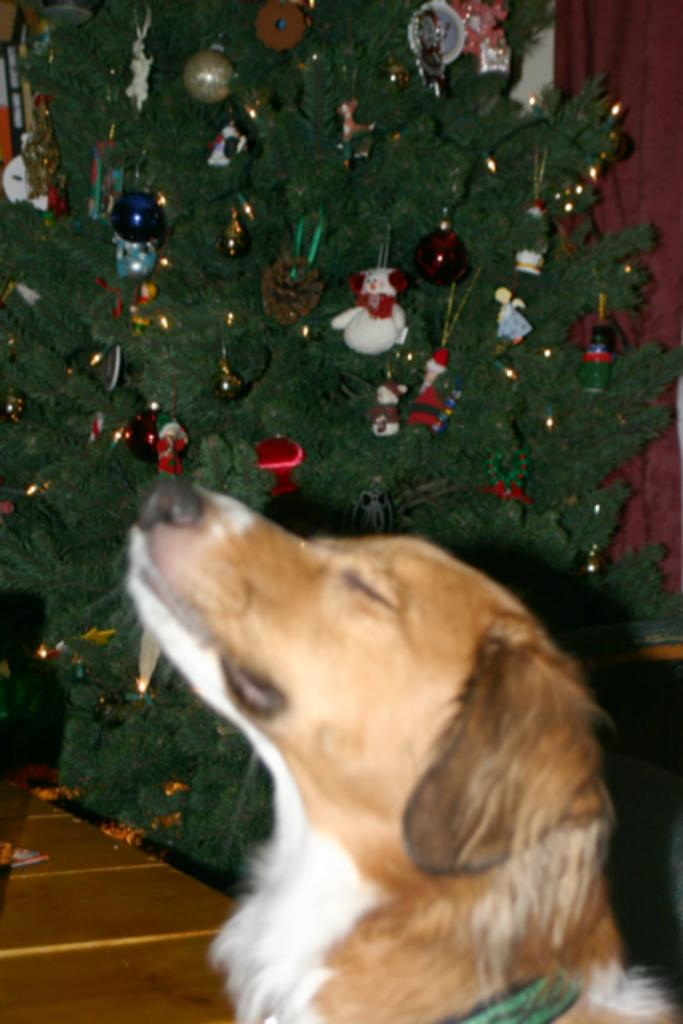What type of animal is present in the image? There is a dog in the image. What holiday-related object can be seen in the image? There is a Christmas tree in the image. What is added to the Christmas tree to make it more festive? The Christmas tree has decorative items. What type of window treatment is visible in the image? There is a curtain in the image. How much money is the dog holding in the image? The dog is not holding any money in the image. What type of base is supporting the Christmas tree in the image? There is no base visible in the image, as the focus is on the dog and the tree itself. 